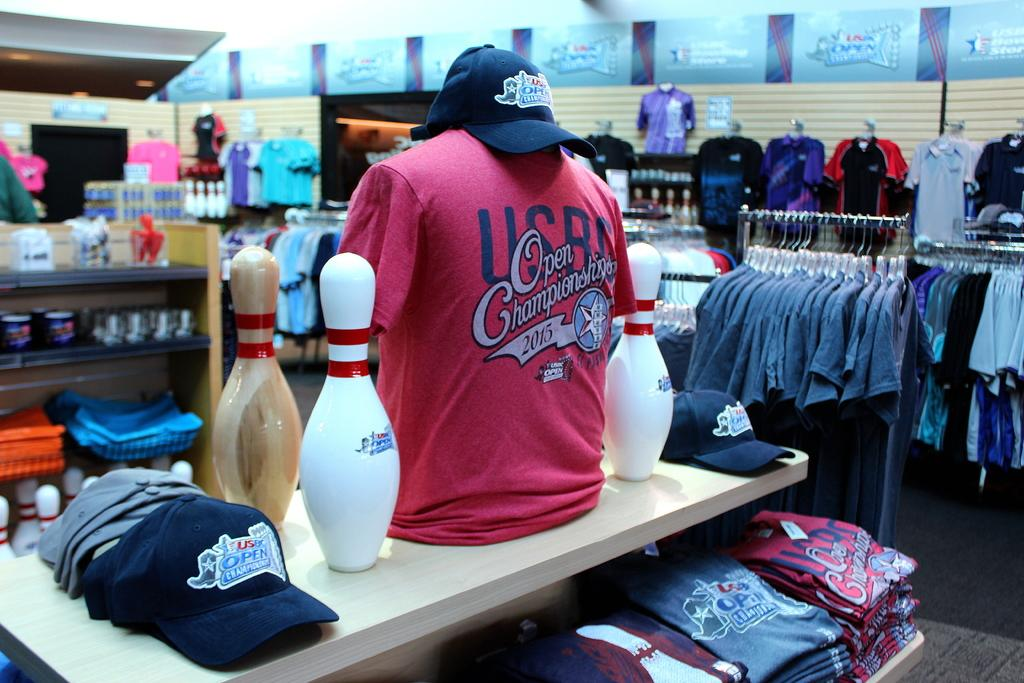<image>
Describe the image concisely. The championship displayed on the red shirt took place in 2015. 